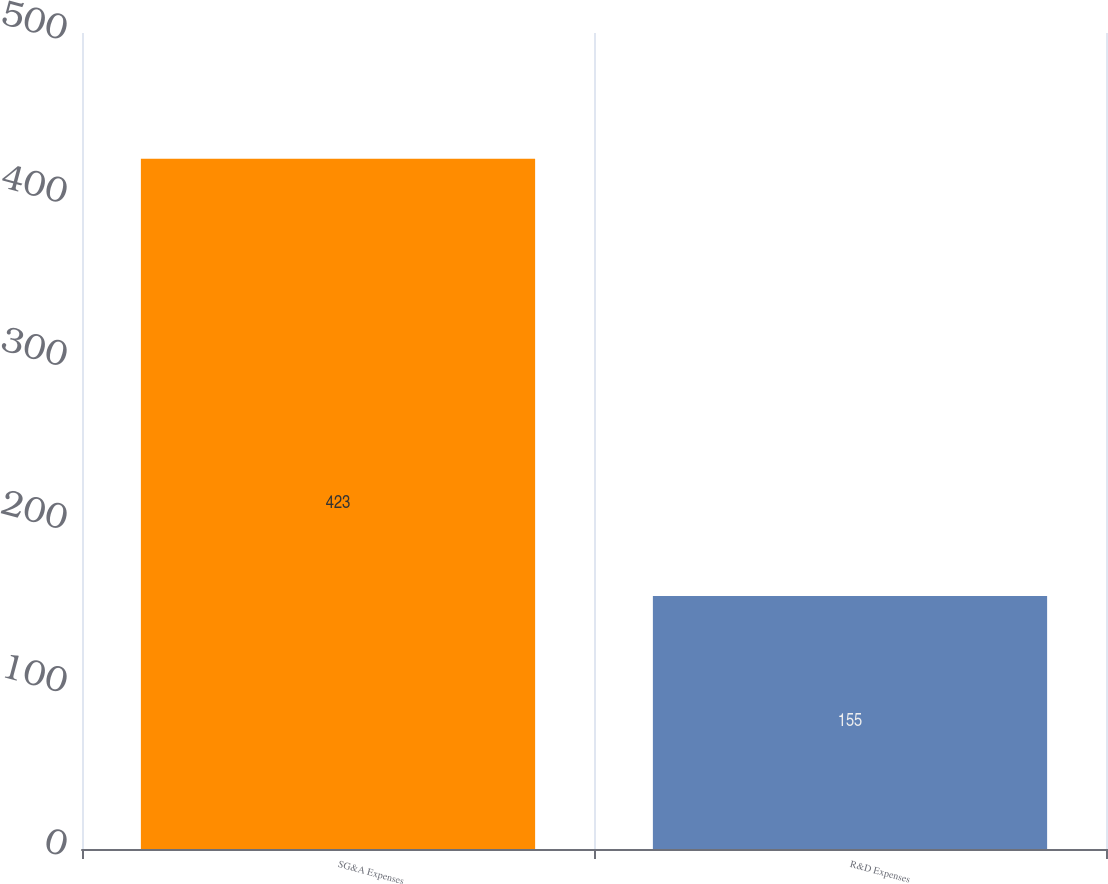<chart> <loc_0><loc_0><loc_500><loc_500><bar_chart><fcel>SG&A Expenses<fcel>R&D Expenses<nl><fcel>423<fcel>155<nl></chart> 